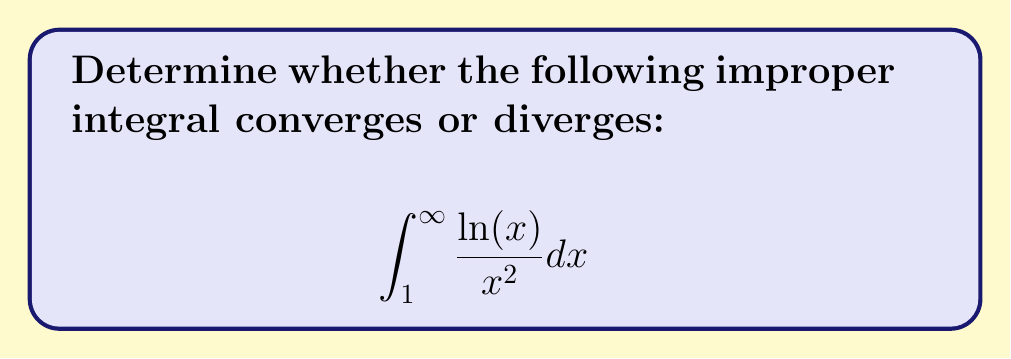What is the answer to this math problem? To determine the convergence or divergence of this improper integral, we'll follow these steps:

1) First, let's consider the behavior of the integrand as $x$ approaches infinity. We can see that both $\ln(x)$ and $\frac{1}{x^2}$ approach zero as $x$ approaches infinity, but $\frac{1}{x^2}$ approaches zero faster.

2) To analyze this more rigorously, we can use the limit comparison test with $\frac{1}{x^{1.5}}$:

   $$\lim_{x \to \infty} \frac{\frac{\ln(x)}{x^2}}{\frac{1}{x^{1.5}}} = \lim_{x \to \infty} \frac{\ln(x)}{x^{0.5}}$$

3) To evaluate this limit, we can use L'Hôpital's rule:

   $$\lim_{x \to \infty} \frac{\ln(x)}{x^{0.5}} = \lim_{x \to \infty} \frac{\frac{1}{x}}{\frac{1}{2}x^{-0.5}} = \lim_{x \to \infty} \frac{2}{x^{0.5}} = 0$$

4) Since this limit is zero, we know that $\frac{\ln(x)}{x^2}$ approaches zero faster than $\frac{1}{x^{1.5}}$ as $x$ approaches infinity.

5) We know that $\int_1^{\infty} \frac{1}{x^{1.5}} dx$ converges (it's a p-integral with $p > 1$). Therefore, by the limit comparison test, our original integral must also converge.

6) To find the exact value of the integral, we can integrate by parts:
   Let $u = \ln(x)$ and $dv = \frac{1}{x^2}dx$
   Then $du = \frac{1}{x}dx$ and $v = -\frac{1}{x}$

   $$\int_1^{\infty} \frac{\ln(x)}{x^2} dx = \left[-\frac{\ln(x)}{x}\right]_1^{\infty} - \int_1^{\infty} -\frac{1}{x^2} dx$$

7) Evaluating the limits and the remaining integral:

   $$= \lim_{b \to \infty} \left(-\frac{\ln(b)}{b} + \frac{\ln(1)}{1}\right) - \left[-\frac{1}{x}\right]_1^{\infty}$$
   $$= (0 - 0) - (0 - 1) = 1$$

Therefore, the improper integral not only converges, but we can determine its exact value.
Answer: The improper integral converges, and its value is 1. 